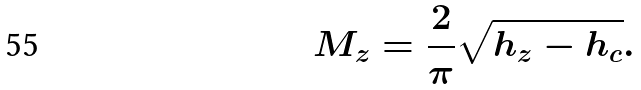<formula> <loc_0><loc_0><loc_500><loc_500>M _ { z } = \frac { 2 } { \pi } \sqrt { h _ { z } - h _ { c } } .</formula> 